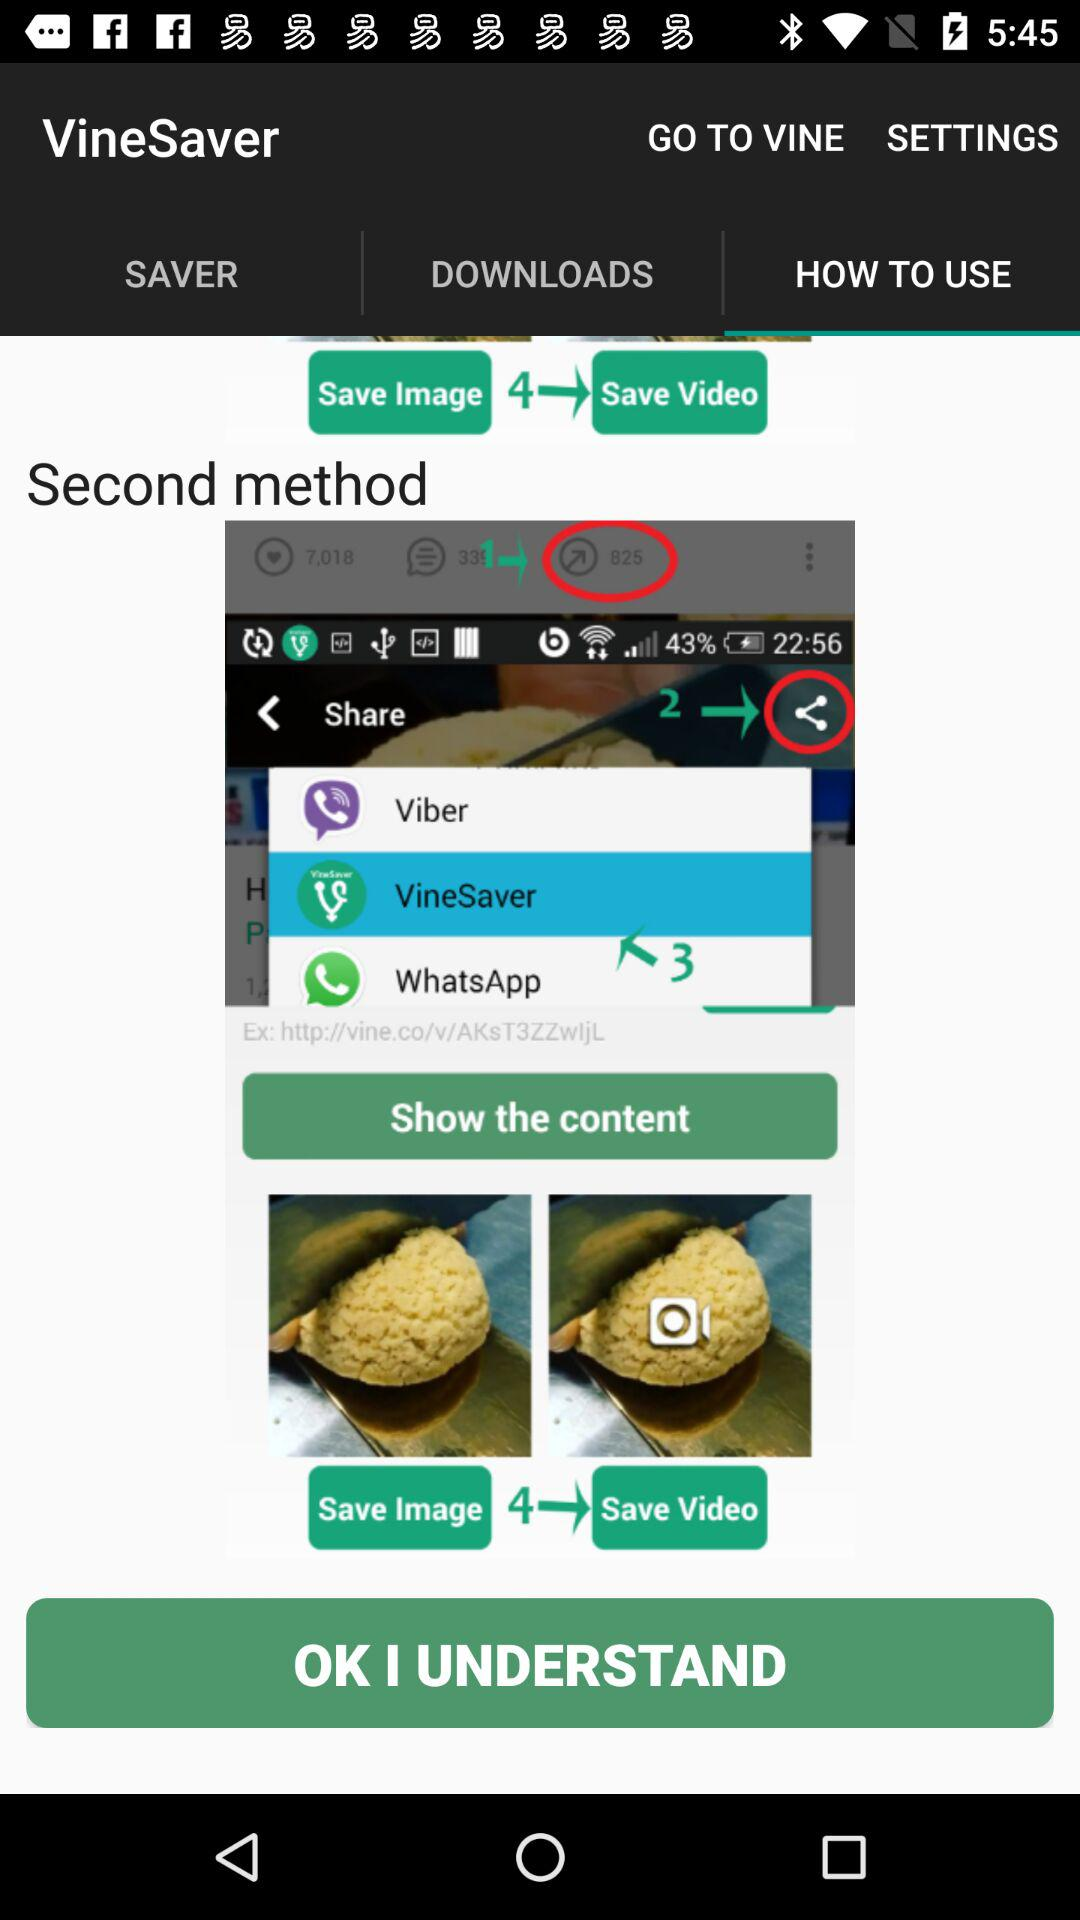How many videos have been downloaded?
When the provided information is insufficient, respond with <no answer>. <no answer> 